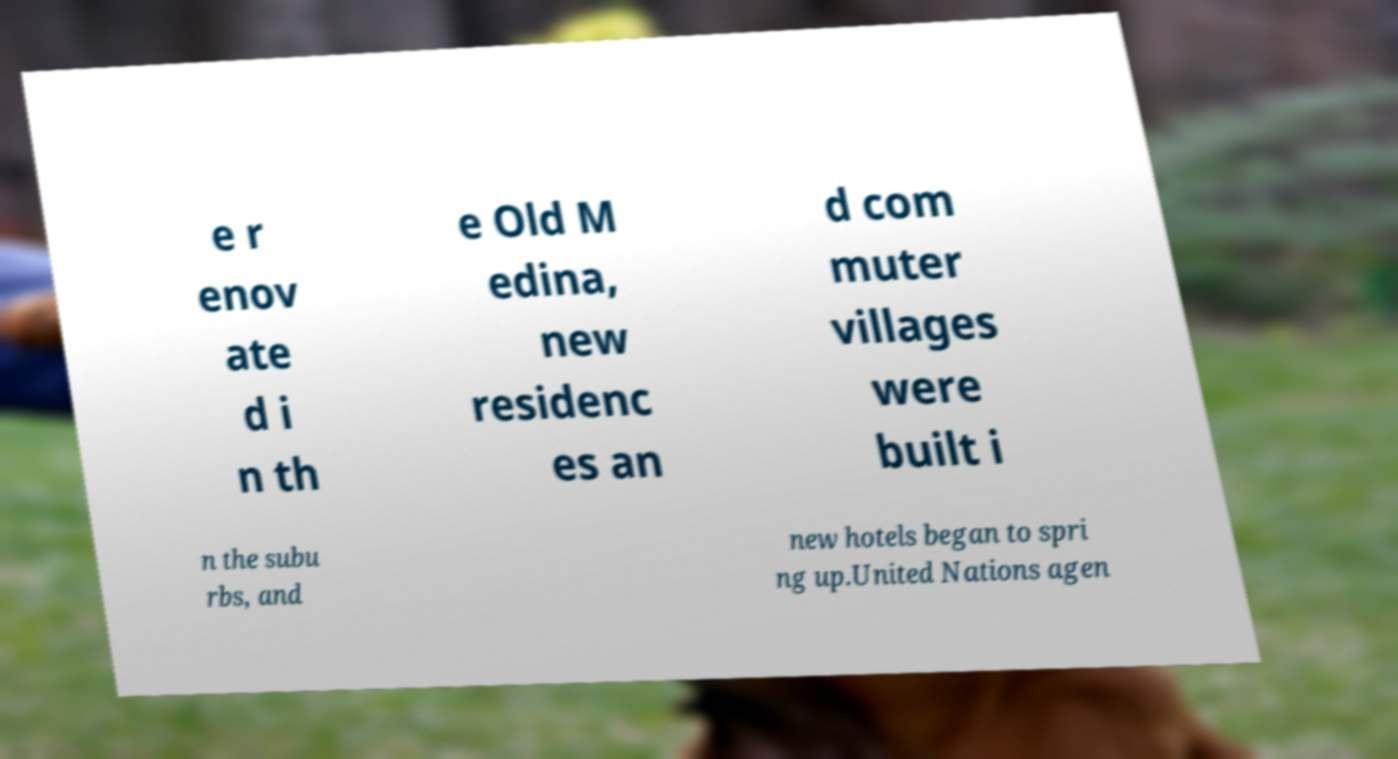For documentation purposes, I need the text within this image transcribed. Could you provide that? e r enov ate d i n th e Old M edina, new residenc es an d com muter villages were built i n the subu rbs, and new hotels began to spri ng up.United Nations agen 